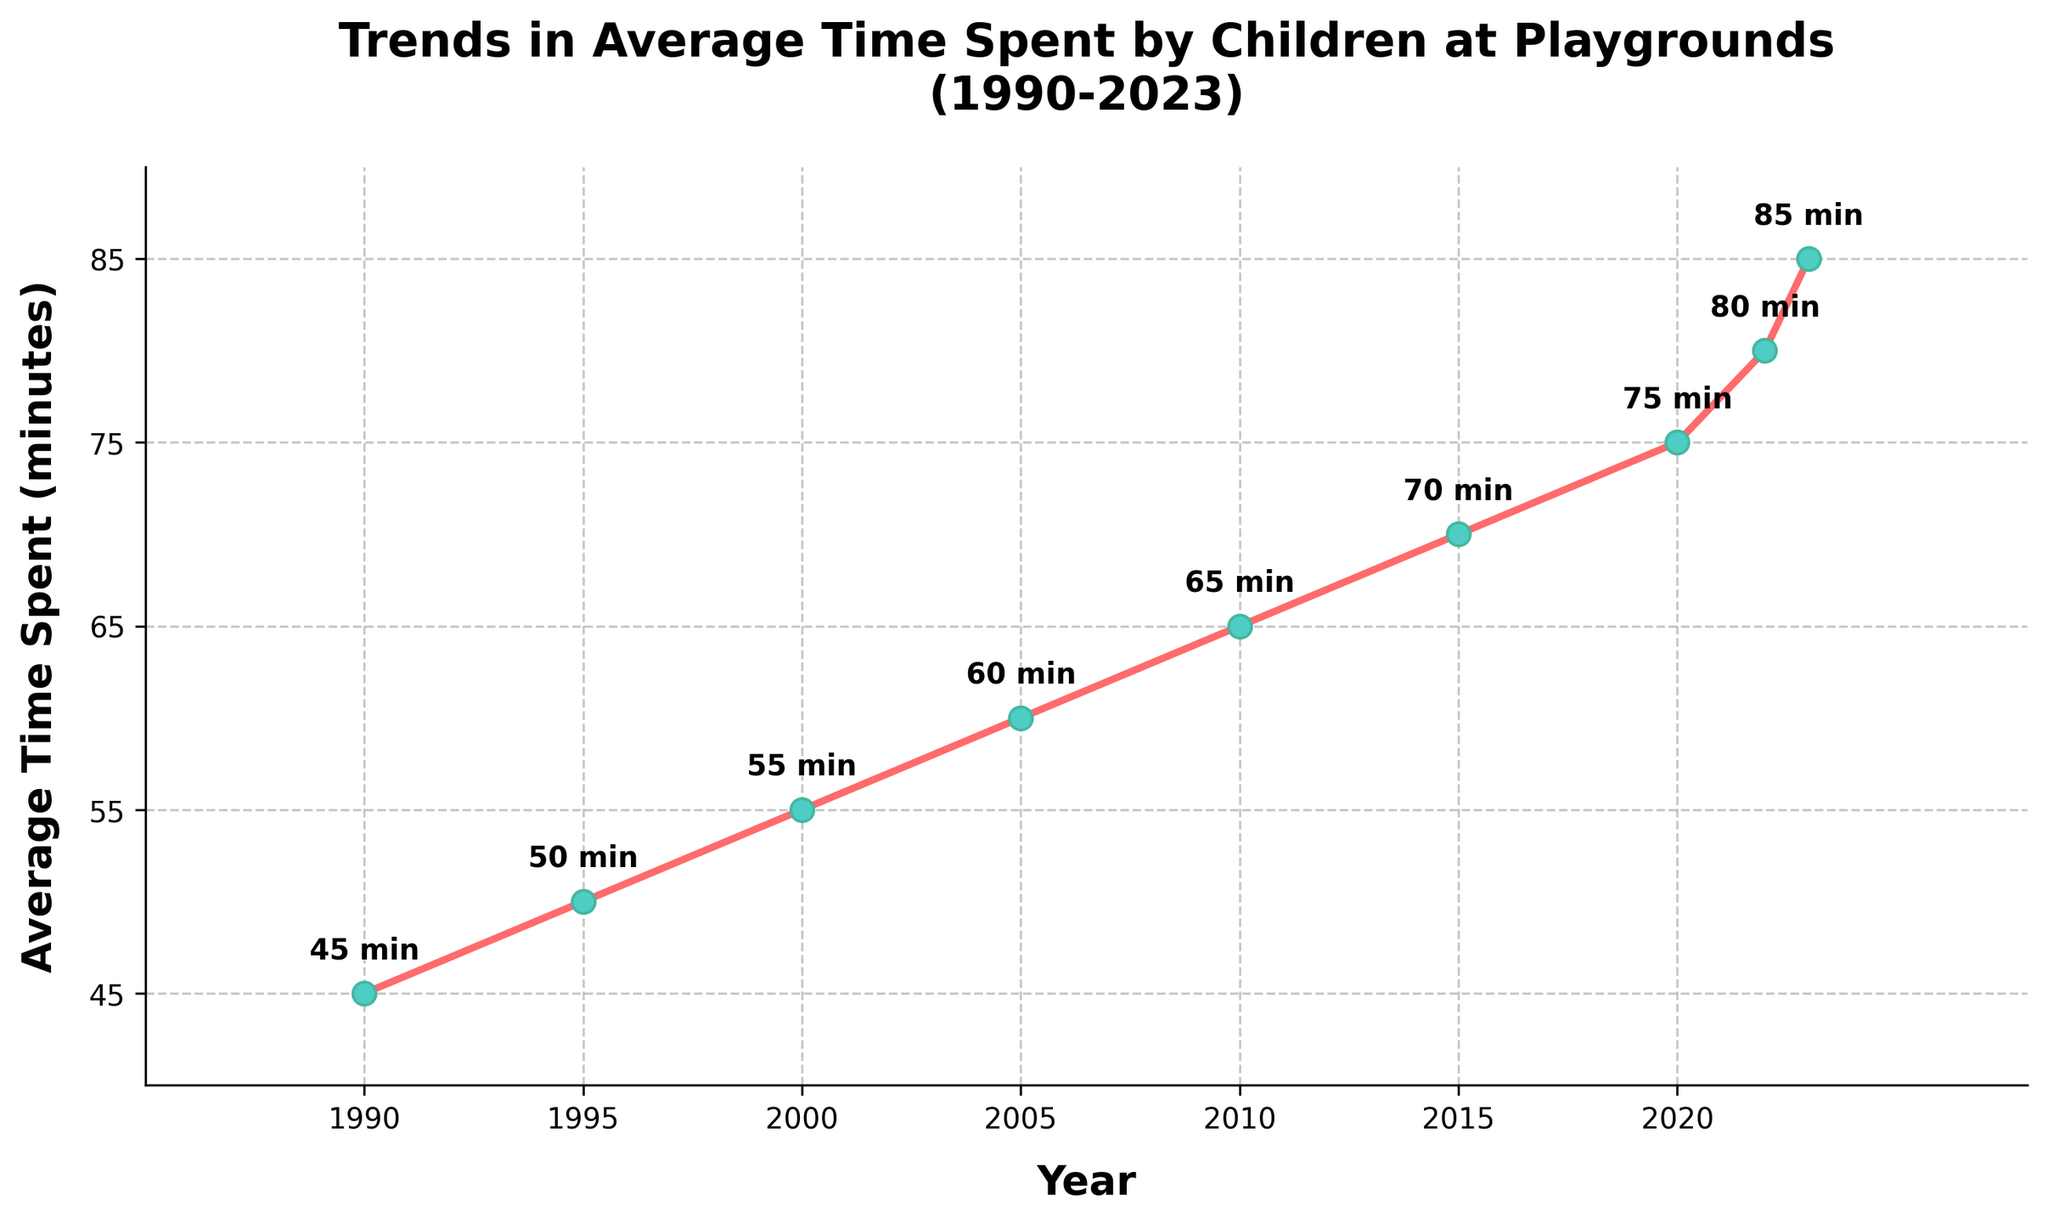What is the overall trend in the average time spent by children at playgrounds from 1990 to 2023? The trend shows a consistent increase in the average time, starting at 45 minutes in 1990 and rising to 85 minutes in 2023.
Answer: Increasing What is the difference in average time spent at playgrounds between 1990 and 2023? The average time spent in 1990 was 45 minutes, and in 2023 it is 85 minutes. The difference is 85 - 45 = 40 minutes.
Answer: 40 minutes Between which consecutive years is the increase in average time spent the highest? The largest increase appears between 2020 (75 minutes) and 2022 (80 minutes), with an increase of 5 minutes.
Answer: 2020 and 2022 What is the average time spent at playgrounds in 2005 and 2015 combined? In 2005, the time was 60 minutes, and in 2015, it was 70 minutes. The combined time is (60 + 70) = 130 minutes.
Answer: 130 minutes How many years are shown in the chart where children spent an average of 65 minutes or more at playgrounds? From 2010 to 2023, children spent 65 minutes or more at playgrounds. This spans 2010, 2015, 2020, 2022, and 2023, making it 5 years.
Answer: 5 years Does the average time spent at playgrounds ever decrease from one data point to the next? Observing the plot, there are no decreases in average time between any two consecutive points; it's always increasing or staying consistent.
Answer: No What's the difference in time spent between the earliest and the latest data points on the chart? The earliest data point is from 1990 with 45 minutes, and the latest is from 2023 with 85 minutes. The difference is 85 - 45 = 40 minutes.
Answer: 40 minutes How does the time spent in 2000 compare to the time spent in 2023? In 2000, children spent 55 minutes on average, whereas in 2023, they spent 85 minutes. There's a 30-minute increase.
Answer: 30 minutes more in 2023 What is the time spent at the playground in the middle year of the data? The middle year between 1990 and 2023 is around 2007.5. Checking the nearest data point for 2005, the time spent is 60 minutes.
Answer: 60 minutes What can be inferred about the trend in playground visits if we assume the increase is linear? If the increase is linear, we can infer that, on average, the time spent at playgrounds increases steadily by about 2 minutes every 2-3 years.
Answer: Steadily increasing by about 2 minutes every 2-3 years 